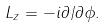<formula> <loc_0><loc_0><loc_500><loc_500>L _ { z } = - i \partial / \partial \phi .</formula> 